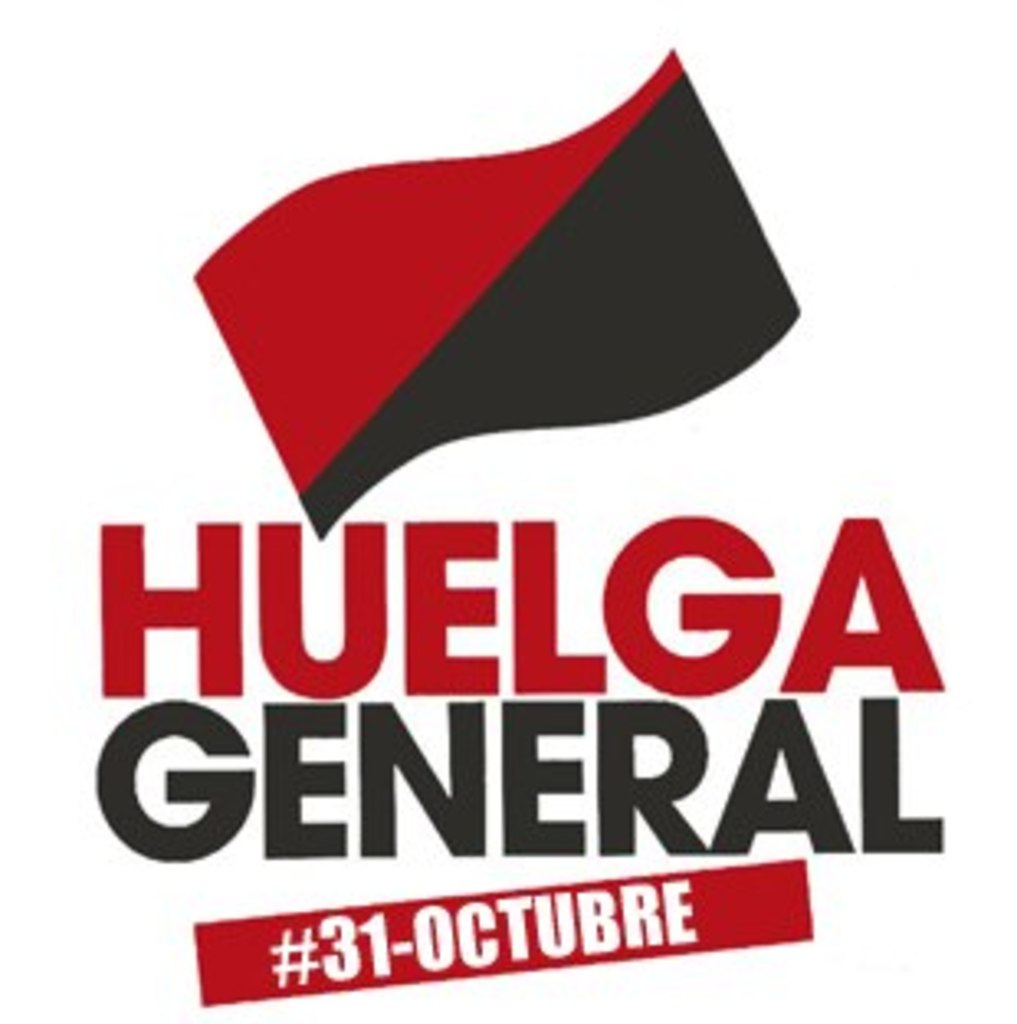How can a general strike impact society and economy? A general strike, like the one advocated in this poster for October 31st, can have profound impacts on both society and the economy. Economically, it can halt production, disrupt supply chains, and cause financial losses to businesses, applying pressure on employers and policymakers to address the demands of workers. Socially, it can raise public awareness about labor issues, strengthen solidarity among workers, and catalyze significant policy changes and reforms aimed at improving workers' rights, wages, and conditions. 